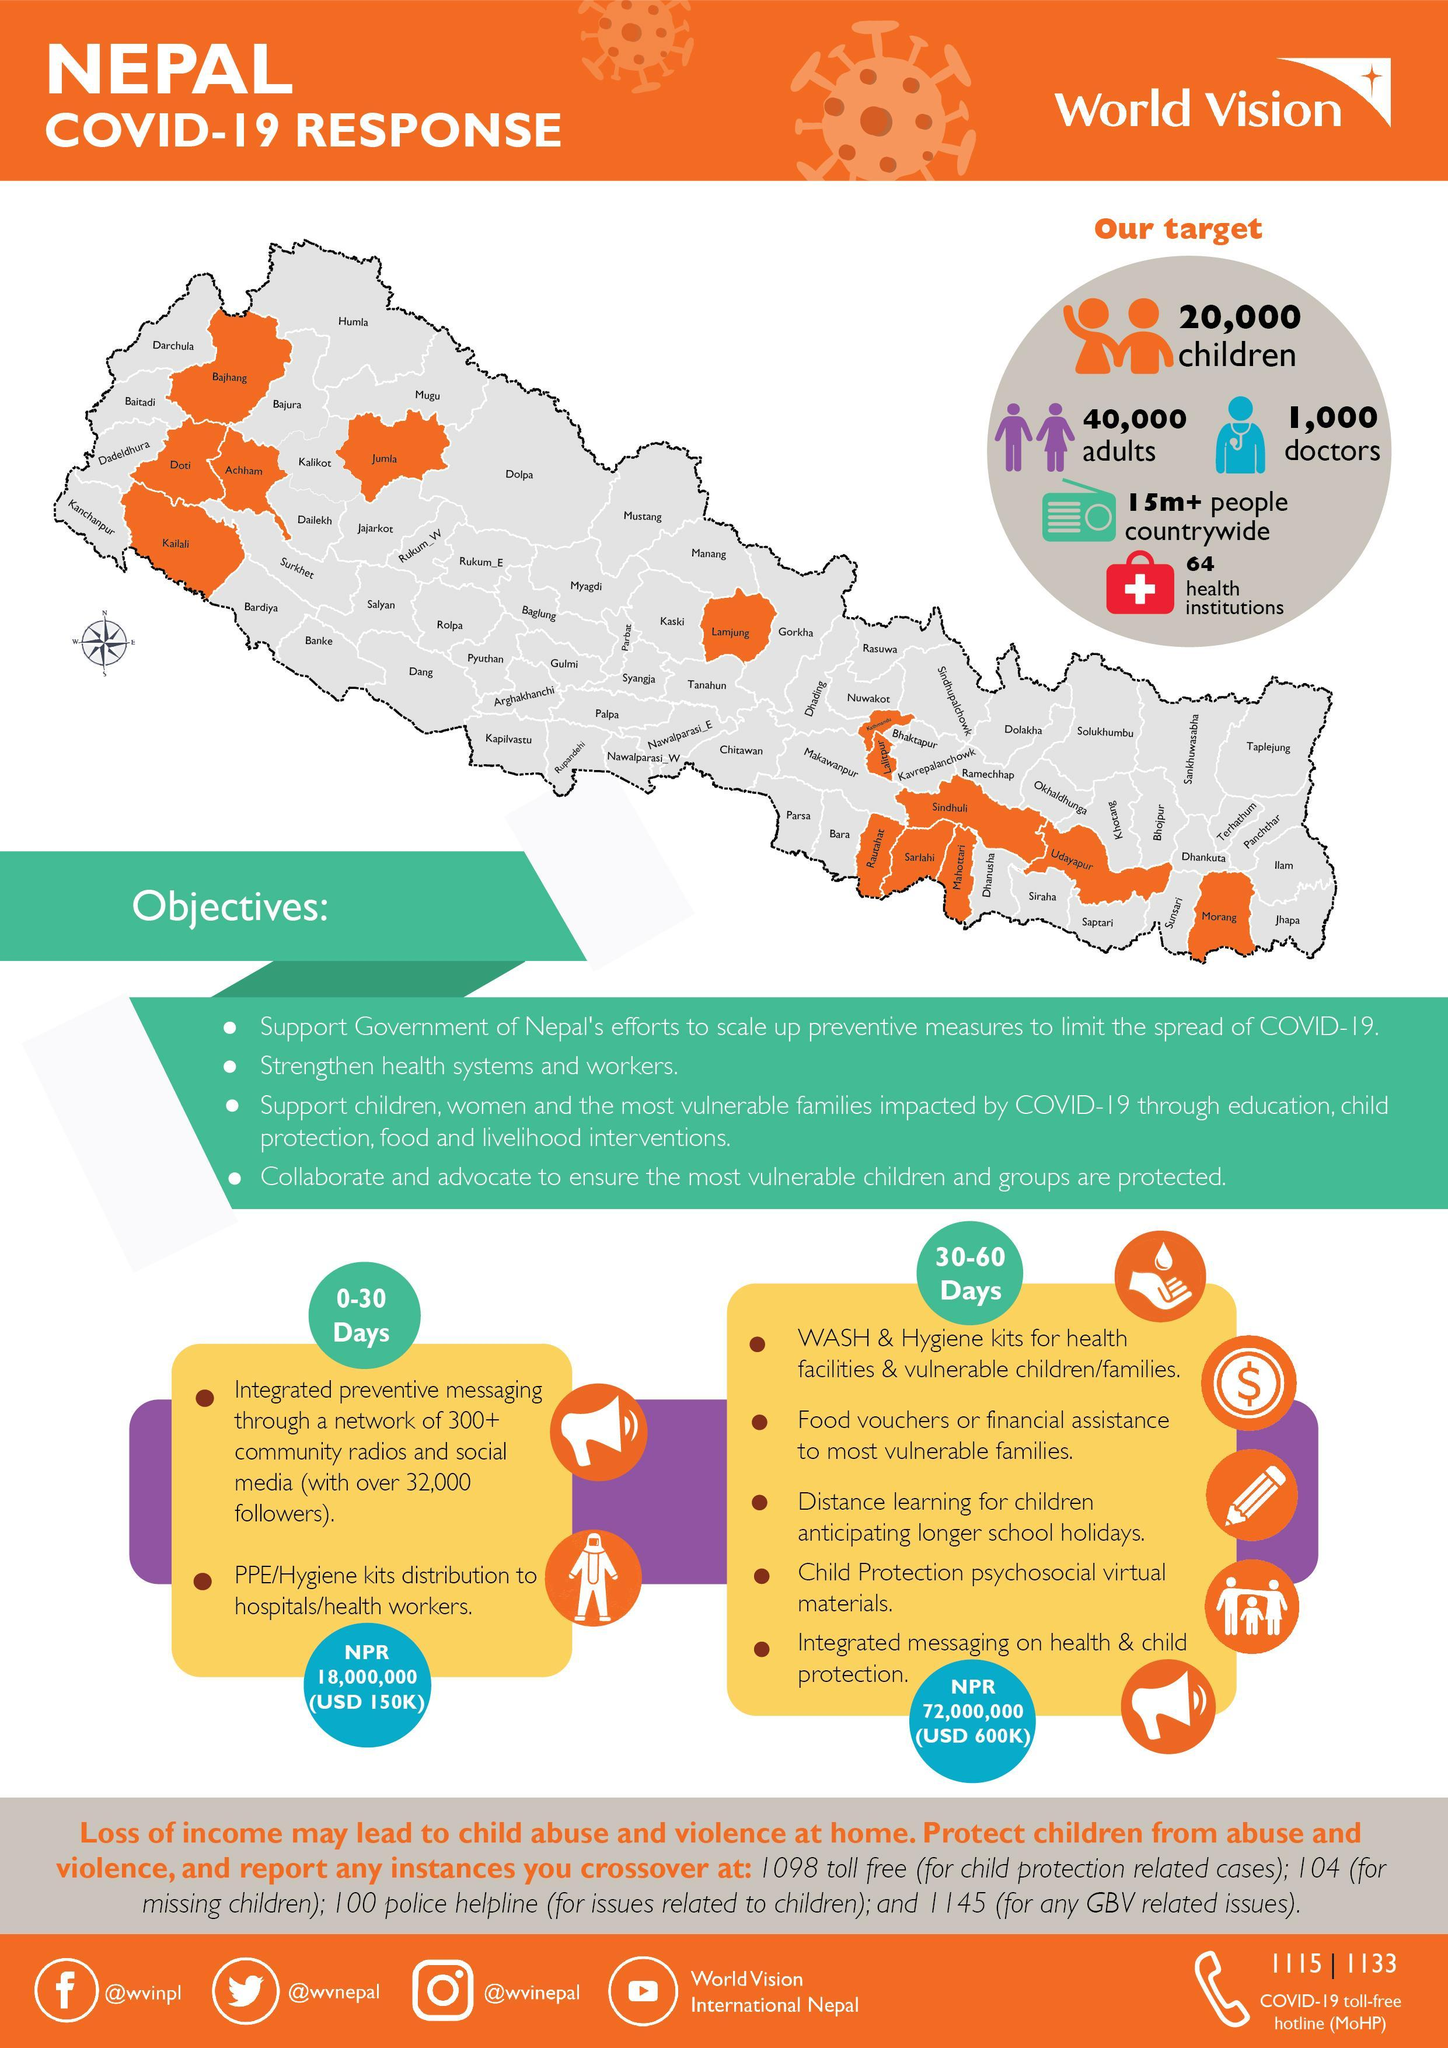How many telephone numbers are given?
Answer the question with a short phrase. 6 Which youtube channel is mentioned? World Vision International Nepal Which Facebook account is mentioned? @wvinpl What is the instagram handle given? @wvinepal What is the twitter handle given? @wvnepal 